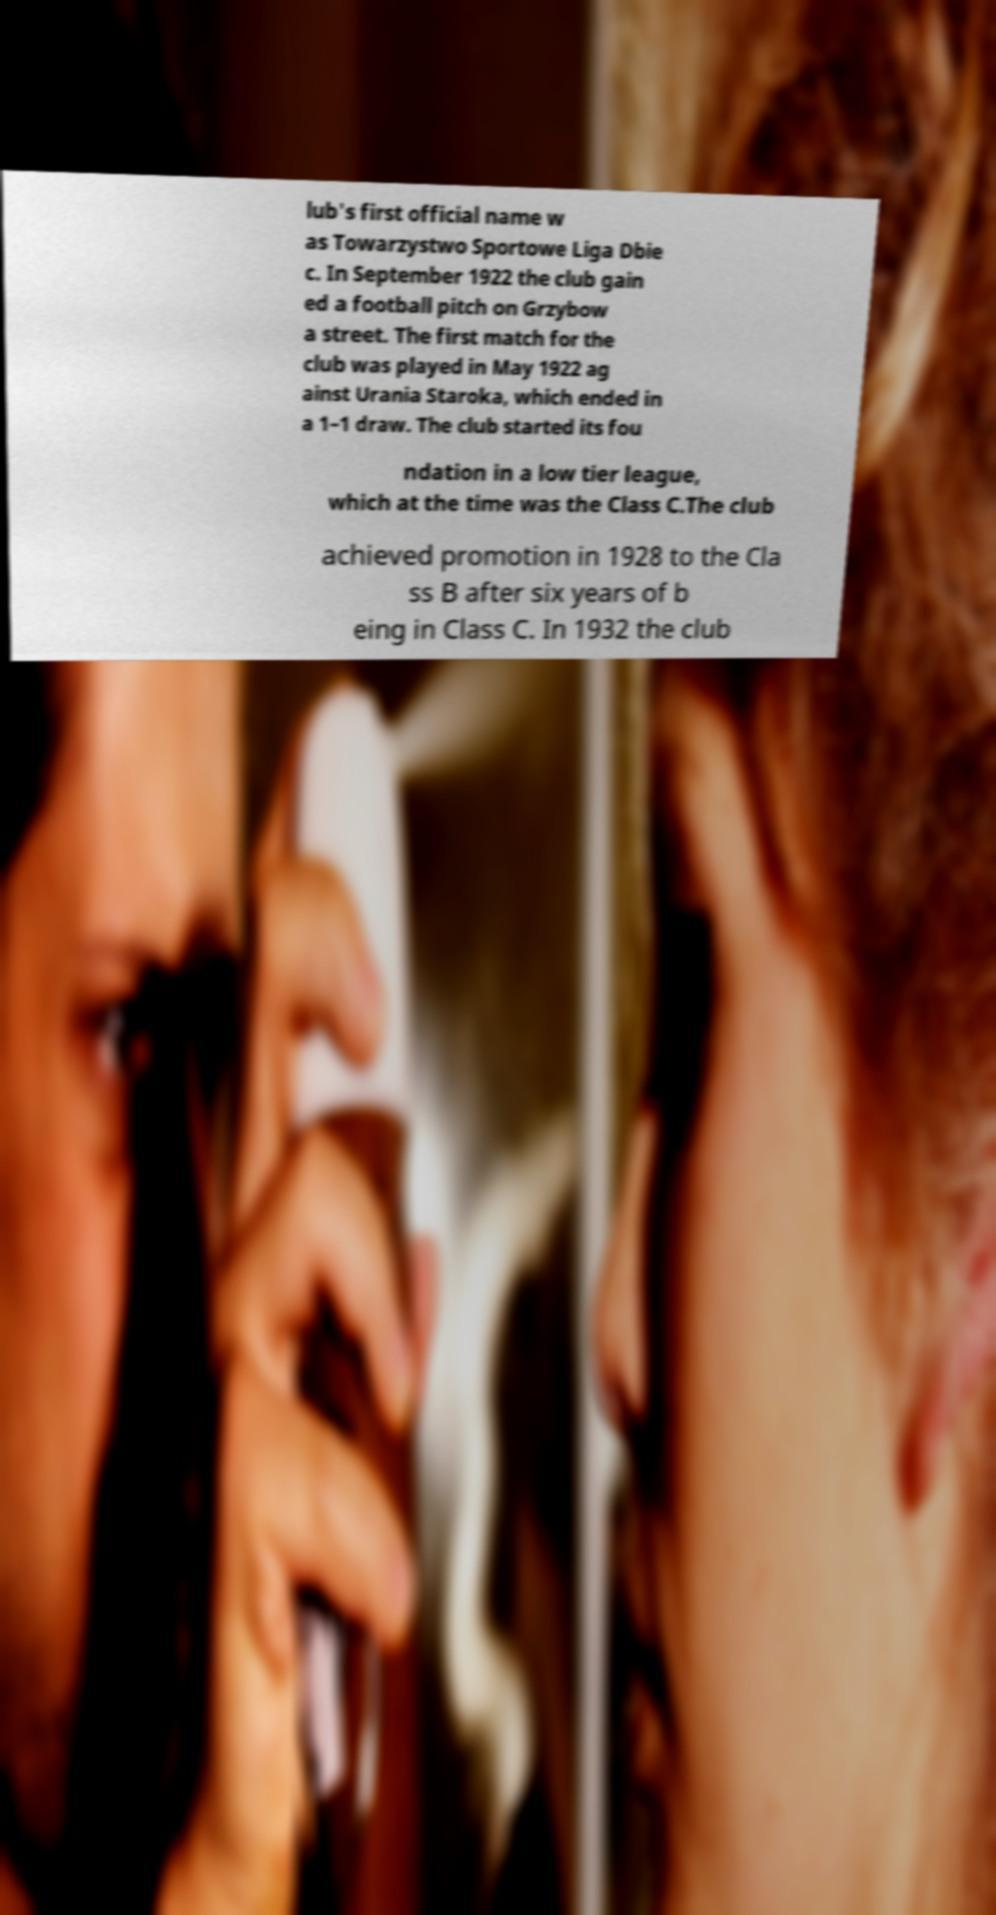I need the written content from this picture converted into text. Can you do that? lub's first official name w as Towarzystwo Sportowe Liga Dbie c. In September 1922 the club gain ed a football pitch on Grzybow a street. The first match for the club was played in May 1922 ag ainst Urania Staroka, which ended in a 1–1 draw. The club started its fou ndation in a low tier league, which at the time was the Class C.The club achieved promotion in 1928 to the Cla ss B after six years of b eing in Class C. In 1932 the club 